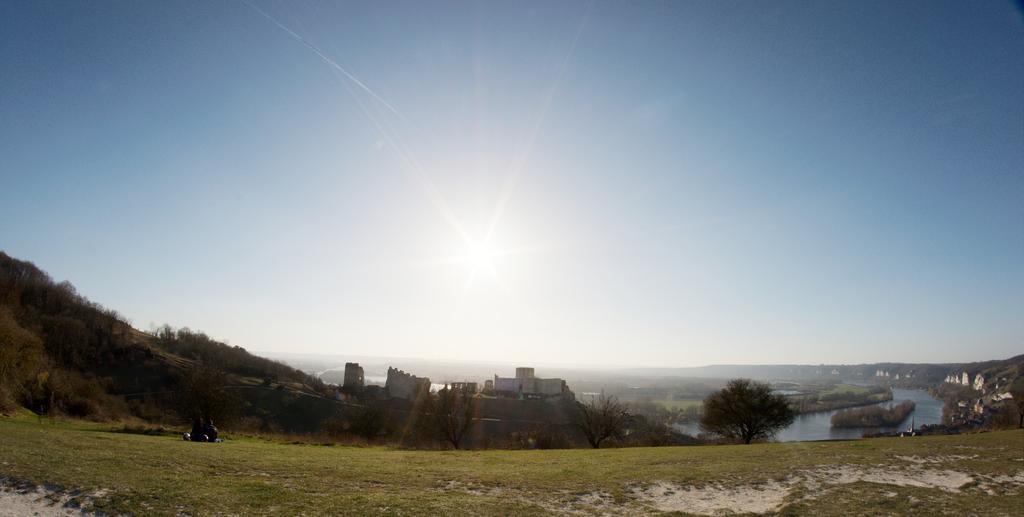Could you give a brief overview of what you see in this image? There is grass on the ground on which, there are two persons sitting. In the background, there are plants, trees and buildings on the hill, there is a lake, there are buildings and trees on the hill, there are mountains and there is sun in the blue sky. 